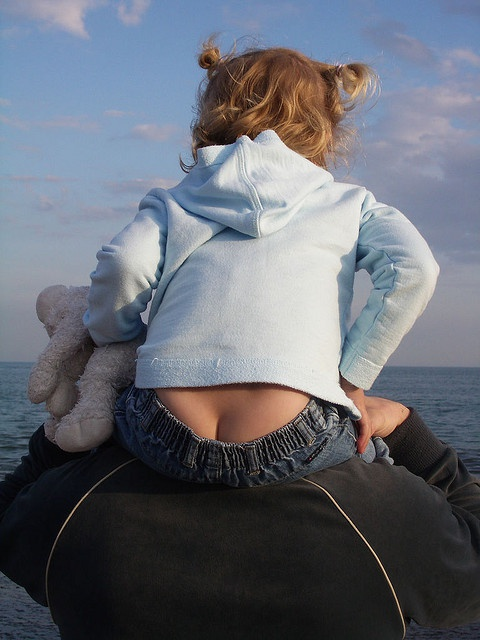Describe the objects in this image and their specific colors. I can see people in gray, lightgray, darkgray, and black tones, people in gray, black, and tan tones, and teddy bear in gray and black tones in this image. 